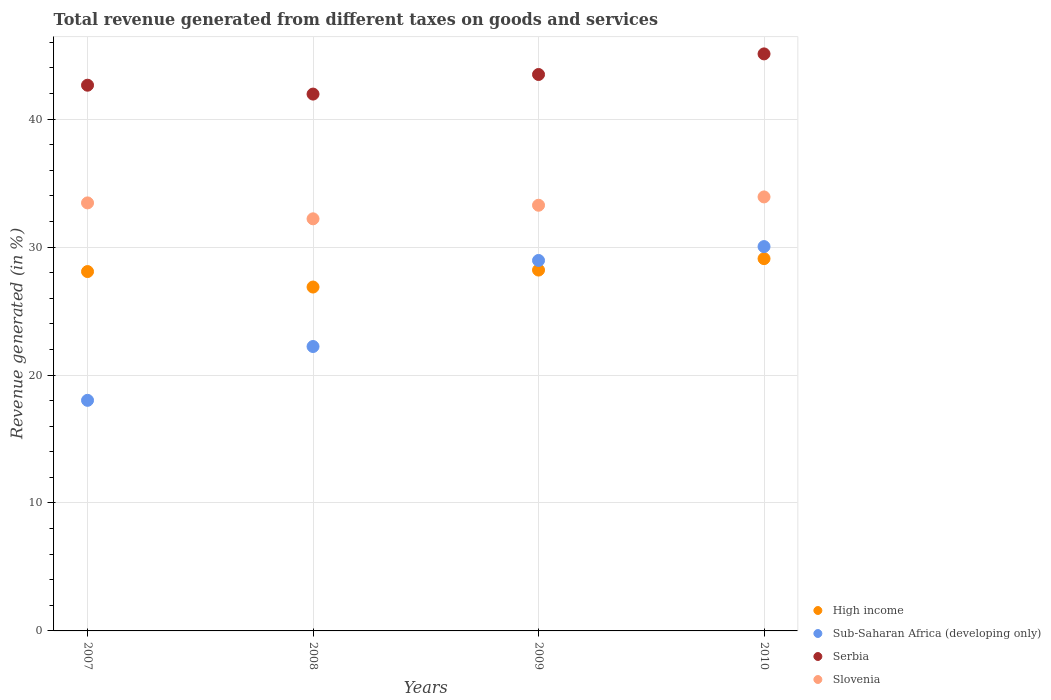What is the total revenue generated in High income in 2007?
Your response must be concise. 28.08. Across all years, what is the maximum total revenue generated in Serbia?
Provide a succinct answer. 45.09. Across all years, what is the minimum total revenue generated in Slovenia?
Your response must be concise. 32.21. In which year was the total revenue generated in High income minimum?
Your answer should be compact. 2008. What is the total total revenue generated in Slovenia in the graph?
Provide a short and direct response. 132.84. What is the difference between the total revenue generated in Sub-Saharan Africa (developing only) in 2008 and that in 2009?
Provide a succinct answer. -6.72. What is the difference between the total revenue generated in Slovenia in 2007 and the total revenue generated in Serbia in 2008?
Offer a very short reply. -8.5. What is the average total revenue generated in Sub-Saharan Africa (developing only) per year?
Ensure brevity in your answer.  24.81. In the year 2007, what is the difference between the total revenue generated in Sub-Saharan Africa (developing only) and total revenue generated in High income?
Give a very brief answer. -10.06. What is the ratio of the total revenue generated in Sub-Saharan Africa (developing only) in 2007 to that in 2008?
Make the answer very short. 0.81. What is the difference between the highest and the second highest total revenue generated in Serbia?
Give a very brief answer. 1.61. What is the difference between the highest and the lowest total revenue generated in Serbia?
Give a very brief answer. 3.14. In how many years, is the total revenue generated in Slovenia greater than the average total revenue generated in Slovenia taken over all years?
Keep it short and to the point. 3. Is the sum of the total revenue generated in Sub-Saharan Africa (developing only) in 2008 and 2009 greater than the maximum total revenue generated in Slovenia across all years?
Give a very brief answer. Yes. Is the total revenue generated in Serbia strictly greater than the total revenue generated in Slovenia over the years?
Offer a terse response. Yes. Is the total revenue generated in Serbia strictly less than the total revenue generated in Slovenia over the years?
Provide a short and direct response. No. Does the graph contain any zero values?
Ensure brevity in your answer.  No. Does the graph contain grids?
Keep it short and to the point. Yes. Where does the legend appear in the graph?
Give a very brief answer. Bottom right. How many legend labels are there?
Offer a terse response. 4. How are the legend labels stacked?
Offer a very short reply. Vertical. What is the title of the graph?
Give a very brief answer. Total revenue generated from different taxes on goods and services. Does "Macao" appear as one of the legend labels in the graph?
Keep it short and to the point. No. What is the label or title of the Y-axis?
Your answer should be very brief. Revenue generated (in %). What is the Revenue generated (in %) in High income in 2007?
Offer a very short reply. 28.08. What is the Revenue generated (in %) of Sub-Saharan Africa (developing only) in 2007?
Your answer should be compact. 18.02. What is the Revenue generated (in %) of Serbia in 2007?
Offer a terse response. 42.65. What is the Revenue generated (in %) of Slovenia in 2007?
Offer a terse response. 33.45. What is the Revenue generated (in %) of High income in 2008?
Make the answer very short. 26.87. What is the Revenue generated (in %) in Sub-Saharan Africa (developing only) in 2008?
Provide a succinct answer. 22.23. What is the Revenue generated (in %) in Serbia in 2008?
Your answer should be compact. 41.95. What is the Revenue generated (in %) in Slovenia in 2008?
Give a very brief answer. 32.21. What is the Revenue generated (in %) of High income in 2009?
Make the answer very short. 28.2. What is the Revenue generated (in %) in Sub-Saharan Africa (developing only) in 2009?
Provide a succinct answer. 28.95. What is the Revenue generated (in %) in Serbia in 2009?
Give a very brief answer. 43.49. What is the Revenue generated (in %) in Slovenia in 2009?
Offer a terse response. 33.27. What is the Revenue generated (in %) in High income in 2010?
Offer a terse response. 29.09. What is the Revenue generated (in %) in Sub-Saharan Africa (developing only) in 2010?
Keep it short and to the point. 30.04. What is the Revenue generated (in %) of Serbia in 2010?
Provide a succinct answer. 45.09. What is the Revenue generated (in %) of Slovenia in 2010?
Provide a short and direct response. 33.92. Across all years, what is the maximum Revenue generated (in %) of High income?
Offer a very short reply. 29.09. Across all years, what is the maximum Revenue generated (in %) of Sub-Saharan Africa (developing only)?
Provide a succinct answer. 30.04. Across all years, what is the maximum Revenue generated (in %) of Serbia?
Provide a short and direct response. 45.09. Across all years, what is the maximum Revenue generated (in %) of Slovenia?
Keep it short and to the point. 33.92. Across all years, what is the minimum Revenue generated (in %) in High income?
Provide a short and direct response. 26.87. Across all years, what is the minimum Revenue generated (in %) in Sub-Saharan Africa (developing only)?
Make the answer very short. 18.02. Across all years, what is the minimum Revenue generated (in %) of Serbia?
Provide a succinct answer. 41.95. Across all years, what is the minimum Revenue generated (in %) of Slovenia?
Provide a succinct answer. 32.21. What is the total Revenue generated (in %) of High income in the graph?
Your response must be concise. 112.25. What is the total Revenue generated (in %) in Sub-Saharan Africa (developing only) in the graph?
Your answer should be compact. 99.24. What is the total Revenue generated (in %) in Serbia in the graph?
Offer a very short reply. 173.18. What is the total Revenue generated (in %) of Slovenia in the graph?
Your answer should be very brief. 132.84. What is the difference between the Revenue generated (in %) in High income in 2007 and that in 2008?
Your answer should be very brief. 1.21. What is the difference between the Revenue generated (in %) in Sub-Saharan Africa (developing only) in 2007 and that in 2008?
Keep it short and to the point. -4.21. What is the difference between the Revenue generated (in %) in Serbia in 2007 and that in 2008?
Keep it short and to the point. 0.69. What is the difference between the Revenue generated (in %) of Slovenia in 2007 and that in 2008?
Your answer should be compact. 1.24. What is the difference between the Revenue generated (in %) of High income in 2007 and that in 2009?
Make the answer very short. -0.12. What is the difference between the Revenue generated (in %) in Sub-Saharan Africa (developing only) in 2007 and that in 2009?
Your answer should be very brief. -10.93. What is the difference between the Revenue generated (in %) in Serbia in 2007 and that in 2009?
Your response must be concise. -0.84. What is the difference between the Revenue generated (in %) in Slovenia in 2007 and that in 2009?
Provide a succinct answer. 0.18. What is the difference between the Revenue generated (in %) of High income in 2007 and that in 2010?
Make the answer very short. -1.01. What is the difference between the Revenue generated (in %) of Sub-Saharan Africa (developing only) in 2007 and that in 2010?
Provide a succinct answer. -12.02. What is the difference between the Revenue generated (in %) in Serbia in 2007 and that in 2010?
Make the answer very short. -2.45. What is the difference between the Revenue generated (in %) of Slovenia in 2007 and that in 2010?
Provide a succinct answer. -0.47. What is the difference between the Revenue generated (in %) of High income in 2008 and that in 2009?
Give a very brief answer. -1.33. What is the difference between the Revenue generated (in %) in Sub-Saharan Africa (developing only) in 2008 and that in 2009?
Provide a succinct answer. -6.72. What is the difference between the Revenue generated (in %) of Serbia in 2008 and that in 2009?
Ensure brevity in your answer.  -1.53. What is the difference between the Revenue generated (in %) of Slovenia in 2008 and that in 2009?
Offer a very short reply. -1.06. What is the difference between the Revenue generated (in %) of High income in 2008 and that in 2010?
Your answer should be compact. -2.22. What is the difference between the Revenue generated (in %) of Sub-Saharan Africa (developing only) in 2008 and that in 2010?
Offer a very short reply. -7.81. What is the difference between the Revenue generated (in %) in Serbia in 2008 and that in 2010?
Make the answer very short. -3.14. What is the difference between the Revenue generated (in %) in Slovenia in 2008 and that in 2010?
Your answer should be compact. -1.71. What is the difference between the Revenue generated (in %) in High income in 2009 and that in 2010?
Offer a very short reply. -0.89. What is the difference between the Revenue generated (in %) in Sub-Saharan Africa (developing only) in 2009 and that in 2010?
Keep it short and to the point. -1.09. What is the difference between the Revenue generated (in %) in Serbia in 2009 and that in 2010?
Offer a very short reply. -1.61. What is the difference between the Revenue generated (in %) of Slovenia in 2009 and that in 2010?
Offer a very short reply. -0.65. What is the difference between the Revenue generated (in %) of High income in 2007 and the Revenue generated (in %) of Sub-Saharan Africa (developing only) in 2008?
Offer a very short reply. 5.86. What is the difference between the Revenue generated (in %) of High income in 2007 and the Revenue generated (in %) of Serbia in 2008?
Your response must be concise. -13.87. What is the difference between the Revenue generated (in %) of High income in 2007 and the Revenue generated (in %) of Slovenia in 2008?
Give a very brief answer. -4.12. What is the difference between the Revenue generated (in %) in Sub-Saharan Africa (developing only) in 2007 and the Revenue generated (in %) in Serbia in 2008?
Your response must be concise. -23.93. What is the difference between the Revenue generated (in %) of Sub-Saharan Africa (developing only) in 2007 and the Revenue generated (in %) of Slovenia in 2008?
Give a very brief answer. -14.19. What is the difference between the Revenue generated (in %) of Serbia in 2007 and the Revenue generated (in %) of Slovenia in 2008?
Your response must be concise. 10.44. What is the difference between the Revenue generated (in %) in High income in 2007 and the Revenue generated (in %) in Sub-Saharan Africa (developing only) in 2009?
Provide a succinct answer. -0.87. What is the difference between the Revenue generated (in %) of High income in 2007 and the Revenue generated (in %) of Serbia in 2009?
Ensure brevity in your answer.  -15.4. What is the difference between the Revenue generated (in %) of High income in 2007 and the Revenue generated (in %) of Slovenia in 2009?
Make the answer very short. -5.18. What is the difference between the Revenue generated (in %) of Sub-Saharan Africa (developing only) in 2007 and the Revenue generated (in %) of Serbia in 2009?
Provide a succinct answer. -25.46. What is the difference between the Revenue generated (in %) in Sub-Saharan Africa (developing only) in 2007 and the Revenue generated (in %) in Slovenia in 2009?
Your answer should be compact. -15.25. What is the difference between the Revenue generated (in %) in Serbia in 2007 and the Revenue generated (in %) in Slovenia in 2009?
Make the answer very short. 9.38. What is the difference between the Revenue generated (in %) of High income in 2007 and the Revenue generated (in %) of Sub-Saharan Africa (developing only) in 2010?
Your response must be concise. -1.95. What is the difference between the Revenue generated (in %) in High income in 2007 and the Revenue generated (in %) in Serbia in 2010?
Your answer should be very brief. -17.01. What is the difference between the Revenue generated (in %) in High income in 2007 and the Revenue generated (in %) in Slovenia in 2010?
Your answer should be very brief. -5.83. What is the difference between the Revenue generated (in %) in Sub-Saharan Africa (developing only) in 2007 and the Revenue generated (in %) in Serbia in 2010?
Provide a succinct answer. -27.07. What is the difference between the Revenue generated (in %) in Sub-Saharan Africa (developing only) in 2007 and the Revenue generated (in %) in Slovenia in 2010?
Ensure brevity in your answer.  -15.9. What is the difference between the Revenue generated (in %) in Serbia in 2007 and the Revenue generated (in %) in Slovenia in 2010?
Make the answer very short. 8.73. What is the difference between the Revenue generated (in %) in High income in 2008 and the Revenue generated (in %) in Sub-Saharan Africa (developing only) in 2009?
Make the answer very short. -2.08. What is the difference between the Revenue generated (in %) of High income in 2008 and the Revenue generated (in %) of Serbia in 2009?
Ensure brevity in your answer.  -16.61. What is the difference between the Revenue generated (in %) in High income in 2008 and the Revenue generated (in %) in Slovenia in 2009?
Your response must be concise. -6.39. What is the difference between the Revenue generated (in %) in Sub-Saharan Africa (developing only) in 2008 and the Revenue generated (in %) in Serbia in 2009?
Keep it short and to the point. -21.26. What is the difference between the Revenue generated (in %) in Sub-Saharan Africa (developing only) in 2008 and the Revenue generated (in %) in Slovenia in 2009?
Make the answer very short. -11.04. What is the difference between the Revenue generated (in %) in Serbia in 2008 and the Revenue generated (in %) in Slovenia in 2009?
Give a very brief answer. 8.69. What is the difference between the Revenue generated (in %) in High income in 2008 and the Revenue generated (in %) in Sub-Saharan Africa (developing only) in 2010?
Ensure brevity in your answer.  -3.16. What is the difference between the Revenue generated (in %) in High income in 2008 and the Revenue generated (in %) in Serbia in 2010?
Provide a succinct answer. -18.22. What is the difference between the Revenue generated (in %) in High income in 2008 and the Revenue generated (in %) in Slovenia in 2010?
Give a very brief answer. -7.04. What is the difference between the Revenue generated (in %) of Sub-Saharan Africa (developing only) in 2008 and the Revenue generated (in %) of Serbia in 2010?
Provide a succinct answer. -22.87. What is the difference between the Revenue generated (in %) of Sub-Saharan Africa (developing only) in 2008 and the Revenue generated (in %) of Slovenia in 2010?
Provide a short and direct response. -11.69. What is the difference between the Revenue generated (in %) in Serbia in 2008 and the Revenue generated (in %) in Slovenia in 2010?
Provide a short and direct response. 8.04. What is the difference between the Revenue generated (in %) in High income in 2009 and the Revenue generated (in %) in Sub-Saharan Africa (developing only) in 2010?
Your answer should be very brief. -1.84. What is the difference between the Revenue generated (in %) in High income in 2009 and the Revenue generated (in %) in Serbia in 2010?
Make the answer very short. -16.89. What is the difference between the Revenue generated (in %) in High income in 2009 and the Revenue generated (in %) in Slovenia in 2010?
Your answer should be very brief. -5.72. What is the difference between the Revenue generated (in %) in Sub-Saharan Africa (developing only) in 2009 and the Revenue generated (in %) in Serbia in 2010?
Your answer should be compact. -16.14. What is the difference between the Revenue generated (in %) in Sub-Saharan Africa (developing only) in 2009 and the Revenue generated (in %) in Slovenia in 2010?
Make the answer very short. -4.97. What is the difference between the Revenue generated (in %) of Serbia in 2009 and the Revenue generated (in %) of Slovenia in 2010?
Ensure brevity in your answer.  9.57. What is the average Revenue generated (in %) of High income per year?
Make the answer very short. 28.06. What is the average Revenue generated (in %) of Sub-Saharan Africa (developing only) per year?
Your answer should be compact. 24.81. What is the average Revenue generated (in %) of Serbia per year?
Give a very brief answer. 43.3. What is the average Revenue generated (in %) of Slovenia per year?
Offer a terse response. 33.21. In the year 2007, what is the difference between the Revenue generated (in %) in High income and Revenue generated (in %) in Sub-Saharan Africa (developing only)?
Ensure brevity in your answer.  10.06. In the year 2007, what is the difference between the Revenue generated (in %) of High income and Revenue generated (in %) of Serbia?
Keep it short and to the point. -14.56. In the year 2007, what is the difference between the Revenue generated (in %) of High income and Revenue generated (in %) of Slovenia?
Your response must be concise. -5.37. In the year 2007, what is the difference between the Revenue generated (in %) in Sub-Saharan Africa (developing only) and Revenue generated (in %) in Serbia?
Keep it short and to the point. -24.63. In the year 2007, what is the difference between the Revenue generated (in %) of Sub-Saharan Africa (developing only) and Revenue generated (in %) of Slovenia?
Your answer should be very brief. -15.43. In the year 2007, what is the difference between the Revenue generated (in %) of Serbia and Revenue generated (in %) of Slovenia?
Your response must be concise. 9.2. In the year 2008, what is the difference between the Revenue generated (in %) in High income and Revenue generated (in %) in Sub-Saharan Africa (developing only)?
Provide a short and direct response. 4.65. In the year 2008, what is the difference between the Revenue generated (in %) in High income and Revenue generated (in %) in Serbia?
Your answer should be compact. -15.08. In the year 2008, what is the difference between the Revenue generated (in %) of High income and Revenue generated (in %) of Slovenia?
Keep it short and to the point. -5.33. In the year 2008, what is the difference between the Revenue generated (in %) in Sub-Saharan Africa (developing only) and Revenue generated (in %) in Serbia?
Your response must be concise. -19.73. In the year 2008, what is the difference between the Revenue generated (in %) of Sub-Saharan Africa (developing only) and Revenue generated (in %) of Slovenia?
Offer a very short reply. -9.98. In the year 2008, what is the difference between the Revenue generated (in %) of Serbia and Revenue generated (in %) of Slovenia?
Offer a terse response. 9.75. In the year 2009, what is the difference between the Revenue generated (in %) in High income and Revenue generated (in %) in Sub-Saharan Africa (developing only)?
Provide a short and direct response. -0.75. In the year 2009, what is the difference between the Revenue generated (in %) of High income and Revenue generated (in %) of Serbia?
Provide a short and direct response. -15.28. In the year 2009, what is the difference between the Revenue generated (in %) of High income and Revenue generated (in %) of Slovenia?
Provide a succinct answer. -5.07. In the year 2009, what is the difference between the Revenue generated (in %) of Sub-Saharan Africa (developing only) and Revenue generated (in %) of Serbia?
Offer a very short reply. -14.53. In the year 2009, what is the difference between the Revenue generated (in %) of Sub-Saharan Africa (developing only) and Revenue generated (in %) of Slovenia?
Your answer should be very brief. -4.32. In the year 2009, what is the difference between the Revenue generated (in %) of Serbia and Revenue generated (in %) of Slovenia?
Your answer should be compact. 10.22. In the year 2010, what is the difference between the Revenue generated (in %) of High income and Revenue generated (in %) of Sub-Saharan Africa (developing only)?
Make the answer very short. -0.94. In the year 2010, what is the difference between the Revenue generated (in %) in High income and Revenue generated (in %) in Serbia?
Provide a short and direct response. -16. In the year 2010, what is the difference between the Revenue generated (in %) of High income and Revenue generated (in %) of Slovenia?
Keep it short and to the point. -4.82. In the year 2010, what is the difference between the Revenue generated (in %) in Sub-Saharan Africa (developing only) and Revenue generated (in %) in Serbia?
Provide a short and direct response. -15.06. In the year 2010, what is the difference between the Revenue generated (in %) in Sub-Saharan Africa (developing only) and Revenue generated (in %) in Slovenia?
Provide a succinct answer. -3.88. In the year 2010, what is the difference between the Revenue generated (in %) of Serbia and Revenue generated (in %) of Slovenia?
Offer a very short reply. 11.18. What is the ratio of the Revenue generated (in %) in High income in 2007 to that in 2008?
Provide a succinct answer. 1.04. What is the ratio of the Revenue generated (in %) of Sub-Saharan Africa (developing only) in 2007 to that in 2008?
Provide a short and direct response. 0.81. What is the ratio of the Revenue generated (in %) in Serbia in 2007 to that in 2008?
Give a very brief answer. 1.02. What is the ratio of the Revenue generated (in %) in Slovenia in 2007 to that in 2008?
Ensure brevity in your answer.  1.04. What is the ratio of the Revenue generated (in %) of Sub-Saharan Africa (developing only) in 2007 to that in 2009?
Offer a terse response. 0.62. What is the ratio of the Revenue generated (in %) of Serbia in 2007 to that in 2009?
Offer a terse response. 0.98. What is the ratio of the Revenue generated (in %) of Slovenia in 2007 to that in 2009?
Ensure brevity in your answer.  1.01. What is the ratio of the Revenue generated (in %) in High income in 2007 to that in 2010?
Your answer should be compact. 0.97. What is the ratio of the Revenue generated (in %) of Sub-Saharan Africa (developing only) in 2007 to that in 2010?
Offer a very short reply. 0.6. What is the ratio of the Revenue generated (in %) of Serbia in 2007 to that in 2010?
Keep it short and to the point. 0.95. What is the ratio of the Revenue generated (in %) in Slovenia in 2007 to that in 2010?
Offer a terse response. 0.99. What is the ratio of the Revenue generated (in %) of High income in 2008 to that in 2009?
Provide a succinct answer. 0.95. What is the ratio of the Revenue generated (in %) in Sub-Saharan Africa (developing only) in 2008 to that in 2009?
Provide a succinct answer. 0.77. What is the ratio of the Revenue generated (in %) in Serbia in 2008 to that in 2009?
Offer a terse response. 0.96. What is the ratio of the Revenue generated (in %) in Slovenia in 2008 to that in 2009?
Provide a succinct answer. 0.97. What is the ratio of the Revenue generated (in %) of High income in 2008 to that in 2010?
Your answer should be very brief. 0.92. What is the ratio of the Revenue generated (in %) of Sub-Saharan Africa (developing only) in 2008 to that in 2010?
Ensure brevity in your answer.  0.74. What is the ratio of the Revenue generated (in %) of Serbia in 2008 to that in 2010?
Provide a short and direct response. 0.93. What is the ratio of the Revenue generated (in %) of Slovenia in 2008 to that in 2010?
Provide a short and direct response. 0.95. What is the ratio of the Revenue generated (in %) in High income in 2009 to that in 2010?
Offer a terse response. 0.97. What is the ratio of the Revenue generated (in %) in Sub-Saharan Africa (developing only) in 2009 to that in 2010?
Keep it short and to the point. 0.96. What is the ratio of the Revenue generated (in %) of Slovenia in 2009 to that in 2010?
Your response must be concise. 0.98. What is the difference between the highest and the second highest Revenue generated (in %) in High income?
Your answer should be very brief. 0.89. What is the difference between the highest and the second highest Revenue generated (in %) in Sub-Saharan Africa (developing only)?
Make the answer very short. 1.09. What is the difference between the highest and the second highest Revenue generated (in %) in Serbia?
Offer a very short reply. 1.61. What is the difference between the highest and the second highest Revenue generated (in %) in Slovenia?
Offer a very short reply. 0.47. What is the difference between the highest and the lowest Revenue generated (in %) of High income?
Offer a terse response. 2.22. What is the difference between the highest and the lowest Revenue generated (in %) of Sub-Saharan Africa (developing only)?
Your answer should be very brief. 12.02. What is the difference between the highest and the lowest Revenue generated (in %) of Serbia?
Provide a short and direct response. 3.14. What is the difference between the highest and the lowest Revenue generated (in %) in Slovenia?
Provide a short and direct response. 1.71. 